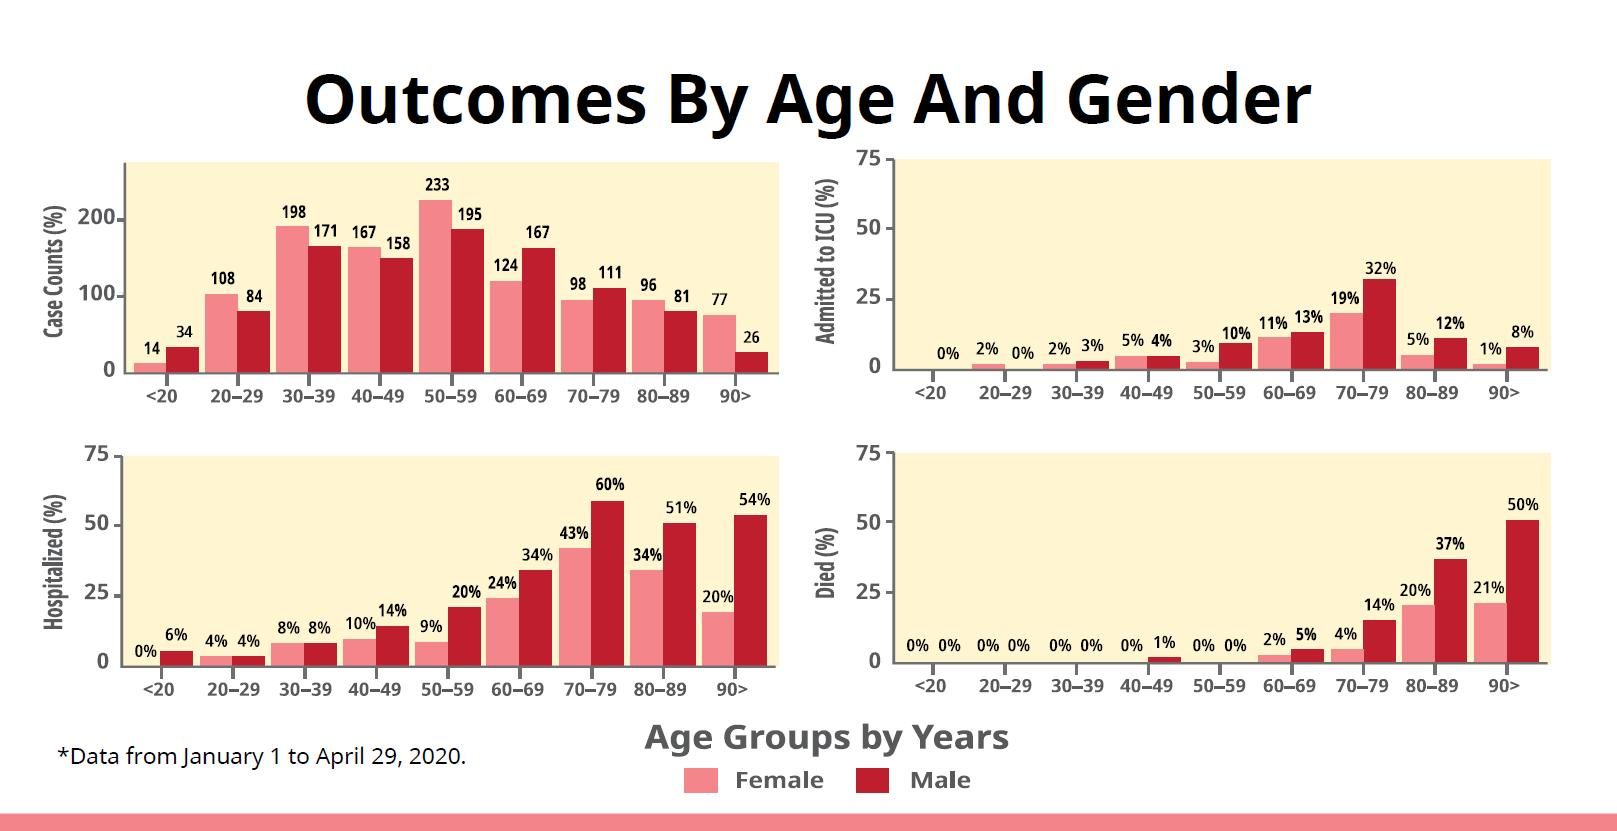Mention a couple of crucial points in this snapshot. The case count of males in the age group of 60-69 is 43, while the case count of females in the same age group is also 43. According to the data, there is a significant difference between hospitalized males and females in the age group of 70-79, with males having a higher hospitalization rate of 17%. According to the data, the total percentage of males and females who died in the age group 70-79 was 18%. The number of cases of a particular disease among males and females in the age group of 70-79 is different, with more cases reported among males than among females. The difference between the hospitalization rates of males and females in the age group of 50-59 is 11%. 